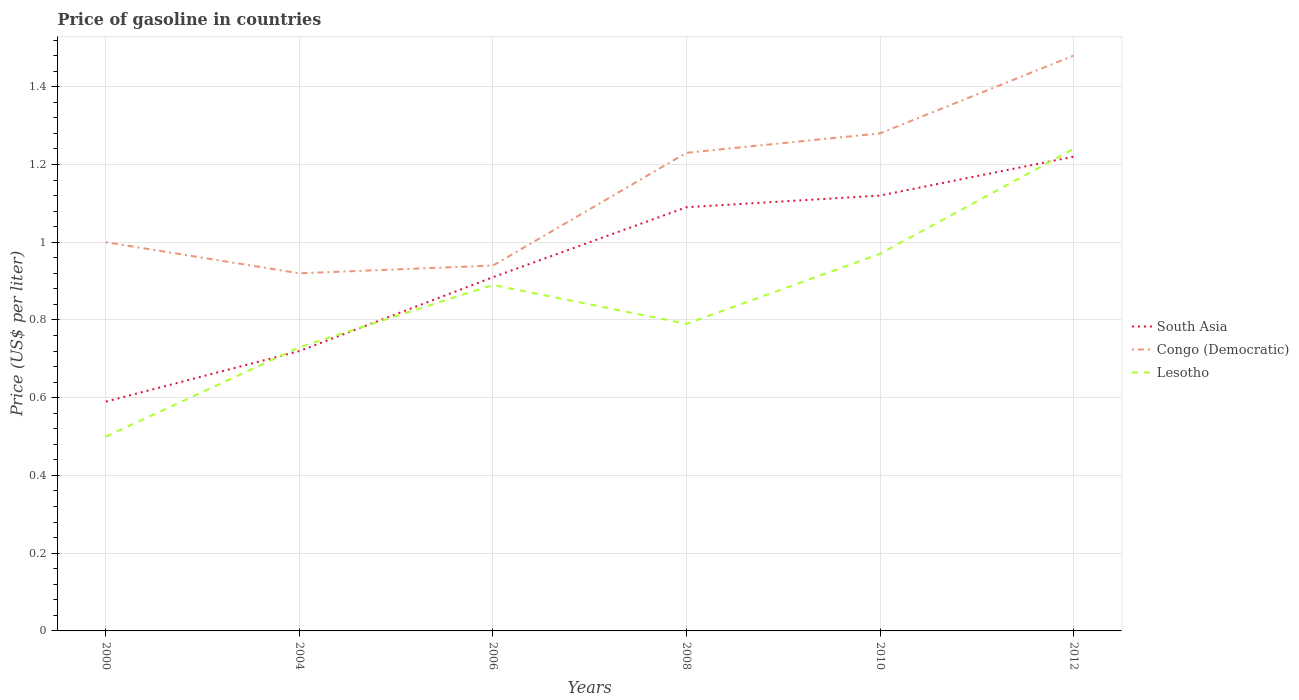Does the line corresponding to Lesotho intersect with the line corresponding to Congo (Democratic)?
Make the answer very short. No. Across all years, what is the maximum price of gasoline in Congo (Democratic)?
Your answer should be very brief. 0.92. What is the total price of gasoline in South Asia in the graph?
Keep it short and to the point. -0.1. What is the difference between the highest and the second highest price of gasoline in Congo (Democratic)?
Give a very brief answer. 0.56. What is the difference between the highest and the lowest price of gasoline in Congo (Democratic)?
Your answer should be very brief. 3. Are the values on the major ticks of Y-axis written in scientific E-notation?
Your answer should be compact. No. Where does the legend appear in the graph?
Offer a very short reply. Center right. How are the legend labels stacked?
Keep it short and to the point. Vertical. What is the title of the graph?
Provide a succinct answer. Price of gasoline in countries. Does "Libya" appear as one of the legend labels in the graph?
Offer a terse response. No. What is the label or title of the X-axis?
Provide a short and direct response. Years. What is the label or title of the Y-axis?
Your response must be concise. Price (US$ per liter). What is the Price (US$ per liter) in South Asia in 2000?
Keep it short and to the point. 0.59. What is the Price (US$ per liter) in Congo (Democratic) in 2000?
Give a very brief answer. 1. What is the Price (US$ per liter) of Lesotho in 2000?
Offer a terse response. 0.5. What is the Price (US$ per liter) in South Asia in 2004?
Ensure brevity in your answer.  0.72. What is the Price (US$ per liter) of Congo (Democratic) in 2004?
Provide a succinct answer. 0.92. What is the Price (US$ per liter) in Lesotho in 2004?
Offer a very short reply. 0.73. What is the Price (US$ per liter) of South Asia in 2006?
Your answer should be very brief. 0.91. What is the Price (US$ per liter) in Lesotho in 2006?
Offer a very short reply. 0.89. What is the Price (US$ per liter) in South Asia in 2008?
Offer a very short reply. 1.09. What is the Price (US$ per liter) of Congo (Democratic) in 2008?
Your response must be concise. 1.23. What is the Price (US$ per liter) of Lesotho in 2008?
Your answer should be very brief. 0.79. What is the Price (US$ per liter) in South Asia in 2010?
Keep it short and to the point. 1.12. What is the Price (US$ per liter) of Congo (Democratic) in 2010?
Provide a short and direct response. 1.28. What is the Price (US$ per liter) of South Asia in 2012?
Offer a very short reply. 1.22. What is the Price (US$ per liter) of Congo (Democratic) in 2012?
Ensure brevity in your answer.  1.48. What is the Price (US$ per liter) of Lesotho in 2012?
Offer a very short reply. 1.24. Across all years, what is the maximum Price (US$ per liter) of South Asia?
Offer a very short reply. 1.22. Across all years, what is the maximum Price (US$ per liter) of Congo (Democratic)?
Provide a succinct answer. 1.48. Across all years, what is the maximum Price (US$ per liter) in Lesotho?
Your response must be concise. 1.24. Across all years, what is the minimum Price (US$ per liter) in South Asia?
Your answer should be very brief. 0.59. Across all years, what is the minimum Price (US$ per liter) in Congo (Democratic)?
Offer a terse response. 0.92. What is the total Price (US$ per liter) of South Asia in the graph?
Give a very brief answer. 5.65. What is the total Price (US$ per liter) in Congo (Democratic) in the graph?
Make the answer very short. 6.85. What is the total Price (US$ per liter) in Lesotho in the graph?
Ensure brevity in your answer.  5.12. What is the difference between the Price (US$ per liter) of South Asia in 2000 and that in 2004?
Ensure brevity in your answer.  -0.13. What is the difference between the Price (US$ per liter) in Lesotho in 2000 and that in 2004?
Your answer should be very brief. -0.23. What is the difference between the Price (US$ per liter) in South Asia in 2000 and that in 2006?
Your answer should be compact. -0.32. What is the difference between the Price (US$ per liter) in Congo (Democratic) in 2000 and that in 2006?
Provide a succinct answer. 0.06. What is the difference between the Price (US$ per liter) in Lesotho in 2000 and that in 2006?
Ensure brevity in your answer.  -0.39. What is the difference between the Price (US$ per liter) in Congo (Democratic) in 2000 and that in 2008?
Ensure brevity in your answer.  -0.23. What is the difference between the Price (US$ per liter) in Lesotho in 2000 and that in 2008?
Keep it short and to the point. -0.29. What is the difference between the Price (US$ per liter) of South Asia in 2000 and that in 2010?
Give a very brief answer. -0.53. What is the difference between the Price (US$ per liter) of Congo (Democratic) in 2000 and that in 2010?
Your answer should be compact. -0.28. What is the difference between the Price (US$ per liter) of Lesotho in 2000 and that in 2010?
Keep it short and to the point. -0.47. What is the difference between the Price (US$ per liter) in South Asia in 2000 and that in 2012?
Provide a short and direct response. -0.63. What is the difference between the Price (US$ per liter) of Congo (Democratic) in 2000 and that in 2012?
Ensure brevity in your answer.  -0.48. What is the difference between the Price (US$ per liter) in Lesotho in 2000 and that in 2012?
Ensure brevity in your answer.  -0.74. What is the difference between the Price (US$ per liter) of South Asia in 2004 and that in 2006?
Offer a very short reply. -0.19. What is the difference between the Price (US$ per liter) in Congo (Democratic) in 2004 and that in 2006?
Your answer should be very brief. -0.02. What is the difference between the Price (US$ per liter) of Lesotho in 2004 and that in 2006?
Keep it short and to the point. -0.16. What is the difference between the Price (US$ per liter) in South Asia in 2004 and that in 2008?
Give a very brief answer. -0.37. What is the difference between the Price (US$ per liter) in Congo (Democratic) in 2004 and that in 2008?
Your answer should be very brief. -0.31. What is the difference between the Price (US$ per liter) in Lesotho in 2004 and that in 2008?
Your response must be concise. -0.06. What is the difference between the Price (US$ per liter) in South Asia in 2004 and that in 2010?
Your answer should be very brief. -0.4. What is the difference between the Price (US$ per liter) of Congo (Democratic) in 2004 and that in 2010?
Your response must be concise. -0.36. What is the difference between the Price (US$ per liter) in Lesotho in 2004 and that in 2010?
Your response must be concise. -0.24. What is the difference between the Price (US$ per liter) of Congo (Democratic) in 2004 and that in 2012?
Provide a short and direct response. -0.56. What is the difference between the Price (US$ per liter) in Lesotho in 2004 and that in 2012?
Offer a terse response. -0.51. What is the difference between the Price (US$ per liter) in South Asia in 2006 and that in 2008?
Make the answer very short. -0.18. What is the difference between the Price (US$ per liter) in Congo (Democratic) in 2006 and that in 2008?
Provide a short and direct response. -0.29. What is the difference between the Price (US$ per liter) in South Asia in 2006 and that in 2010?
Ensure brevity in your answer.  -0.21. What is the difference between the Price (US$ per liter) of Congo (Democratic) in 2006 and that in 2010?
Your response must be concise. -0.34. What is the difference between the Price (US$ per liter) of Lesotho in 2006 and that in 2010?
Offer a very short reply. -0.08. What is the difference between the Price (US$ per liter) in South Asia in 2006 and that in 2012?
Make the answer very short. -0.31. What is the difference between the Price (US$ per liter) in Congo (Democratic) in 2006 and that in 2012?
Provide a succinct answer. -0.54. What is the difference between the Price (US$ per liter) in Lesotho in 2006 and that in 2012?
Keep it short and to the point. -0.35. What is the difference between the Price (US$ per liter) of South Asia in 2008 and that in 2010?
Ensure brevity in your answer.  -0.03. What is the difference between the Price (US$ per liter) of Lesotho in 2008 and that in 2010?
Offer a very short reply. -0.18. What is the difference between the Price (US$ per liter) of South Asia in 2008 and that in 2012?
Your answer should be compact. -0.13. What is the difference between the Price (US$ per liter) of Lesotho in 2008 and that in 2012?
Provide a succinct answer. -0.45. What is the difference between the Price (US$ per liter) in Lesotho in 2010 and that in 2012?
Your answer should be compact. -0.27. What is the difference between the Price (US$ per liter) in South Asia in 2000 and the Price (US$ per liter) in Congo (Democratic) in 2004?
Your answer should be very brief. -0.33. What is the difference between the Price (US$ per liter) of South Asia in 2000 and the Price (US$ per liter) of Lesotho in 2004?
Ensure brevity in your answer.  -0.14. What is the difference between the Price (US$ per liter) of Congo (Democratic) in 2000 and the Price (US$ per liter) of Lesotho in 2004?
Your answer should be very brief. 0.27. What is the difference between the Price (US$ per liter) of South Asia in 2000 and the Price (US$ per liter) of Congo (Democratic) in 2006?
Offer a very short reply. -0.35. What is the difference between the Price (US$ per liter) in South Asia in 2000 and the Price (US$ per liter) in Lesotho in 2006?
Offer a terse response. -0.3. What is the difference between the Price (US$ per liter) in Congo (Democratic) in 2000 and the Price (US$ per liter) in Lesotho in 2006?
Provide a succinct answer. 0.11. What is the difference between the Price (US$ per liter) in South Asia in 2000 and the Price (US$ per liter) in Congo (Democratic) in 2008?
Keep it short and to the point. -0.64. What is the difference between the Price (US$ per liter) of Congo (Democratic) in 2000 and the Price (US$ per liter) of Lesotho in 2008?
Your answer should be very brief. 0.21. What is the difference between the Price (US$ per liter) in South Asia in 2000 and the Price (US$ per liter) in Congo (Democratic) in 2010?
Keep it short and to the point. -0.69. What is the difference between the Price (US$ per liter) of South Asia in 2000 and the Price (US$ per liter) of Lesotho in 2010?
Keep it short and to the point. -0.38. What is the difference between the Price (US$ per liter) in Congo (Democratic) in 2000 and the Price (US$ per liter) in Lesotho in 2010?
Make the answer very short. 0.03. What is the difference between the Price (US$ per liter) of South Asia in 2000 and the Price (US$ per liter) of Congo (Democratic) in 2012?
Keep it short and to the point. -0.89. What is the difference between the Price (US$ per liter) of South Asia in 2000 and the Price (US$ per liter) of Lesotho in 2012?
Provide a succinct answer. -0.65. What is the difference between the Price (US$ per liter) of Congo (Democratic) in 2000 and the Price (US$ per liter) of Lesotho in 2012?
Offer a terse response. -0.24. What is the difference between the Price (US$ per liter) of South Asia in 2004 and the Price (US$ per liter) of Congo (Democratic) in 2006?
Offer a terse response. -0.22. What is the difference between the Price (US$ per liter) in South Asia in 2004 and the Price (US$ per liter) in Lesotho in 2006?
Offer a terse response. -0.17. What is the difference between the Price (US$ per liter) of Congo (Democratic) in 2004 and the Price (US$ per liter) of Lesotho in 2006?
Your response must be concise. 0.03. What is the difference between the Price (US$ per liter) in South Asia in 2004 and the Price (US$ per liter) in Congo (Democratic) in 2008?
Provide a succinct answer. -0.51. What is the difference between the Price (US$ per liter) in South Asia in 2004 and the Price (US$ per liter) in Lesotho in 2008?
Provide a succinct answer. -0.07. What is the difference between the Price (US$ per liter) in Congo (Democratic) in 2004 and the Price (US$ per liter) in Lesotho in 2008?
Make the answer very short. 0.13. What is the difference between the Price (US$ per liter) of South Asia in 2004 and the Price (US$ per liter) of Congo (Democratic) in 2010?
Ensure brevity in your answer.  -0.56. What is the difference between the Price (US$ per liter) in Congo (Democratic) in 2004 and the Price (US$ per liter) in Lesotho in 2010?
Your answer should be compact. -0.05. What is the difference between the Price (US$ per liter) of South Asia in 2004 and the Price (US$ per liter) of Congo (Democratic) in 2012?
Your answer should be very brief. -0.76. What is the difference between the Price (US$ per liter) in South Asia in 2004 and the Price (US$ per liter) in Lesotho in 2012?
Make the answer very short. -0.52. What is the difference between the Price (US$ per liter) in Congo (Democratic) in 2004 and the Price (US$ per liter) in Lesotho in 2012?
Make the answer very short. -0.32. What is the difference between the Price (US$ per liter) of South Asia in 2006 and the Price (US$ per liter) of Congo (Democratic) in 2008?
Your answer should be very brief. -0.32. What is the difference between the Price (US$ per liter) of South Asia in 2006 and the Price (US$ per liter) of Lesotho in 2008?
Keep it short and to the point. 0.12. What is the difference between the Price (US$ per liter) in Congo (Democratic) in 2006 and the Price (US$ per liter) in Lesotho in 2008?
Make the answer very short. 0.15. What is the difference between the Price (US$ per liter) of South Asia in 2006 and the Price (US$ per liter) of Congo (Democratic) in 2010?
Give a very brief answer. -0.37. What is the difference between the Price (US$ per liter) of South Asia in 2006 and the Price (US$ per liter) of Lesotho in 2010?
Make the answer very short. -0.06. What is the difference between the Price (US$ per liter) of Congo (Democratic) in 2006 and the Price (US$ per liter) of Lesotho in 2010?
Provide a succinct answer. -0.03. What is the difference between the Price (US$ per liter) of South Asia in 2006 and the Price (US$ per liter) of Congo (Democratic) in 2012?
Ensure brevity in your answer.  -0.57. What is the difference between the Price (US$ per liter) of South Asia in 2006 and the Price (US$ per liter) of Lesotho in 2012?
Provide a short and direct response. -0.33. What is the difference between the Price (US$ per liter) of Congo (Democratic) in 2006 and the Price (US$ per liter) of Lesotho in 2012?
Offer a terse response. -0.3. What is the difference between the Price (US$ per liter) in South Asia in 2008 and the Price (US$ per liter) in Congo (Democratic) in 2010?
Keep it short and to the point. -0.19. What is the difference between the Price (US$ per liter) of South Asia in 2008 and the Price (US$ per liter) of Lesotho in 2010?
Provide a short and direct response. 0.12. What is the difference between the Price (US$ per liter) of Congo (Democratic) in 2008 and the Price (US$ per liter) of Lesotho in 2010?
Keep it short and to the point. 0.26. What is the difference between the Price (US$ per liter) in South Asia in 2008 and the Price (US$ per liter) in Congo (Democratic) in 2012?
Your answer should be very brief. -0.39. What is the difference between the Price (US$ per liter) of South Asia in 2008 and the Price (US$ per liter) of Lesotho in 2012?
Offer a very short reply. -0.15. What is the difference between the Price (US$ per liter) of Congo (Democratic) in 2008 and the Price (US$ per liter) of Lesotho in 2012?
Give a very brief answer. -0.01. What is the difference between the Price (US$ per liter) in South Asia in 2010 and the Price (US$ per liter) in Congo (Democratic) in 2012?
Your response must be concise. -0.36. What is the difference between the Price (US$ per liter) of South Asia in 2010 and the Price (US$ per liter) of Lesotho in 2012?
Your response must be concise. -0.12. What is the average Price (US$ per liter) of South Asia per year?
Your response must be concise. 0.94. What is the average Price (US$ per liter) of Congo (Democratic) per year?
Provide a succinct answer. 1.14. What is the average Price (US$ per liter) in Lesotho per year?
Keep it short and to the point. 0.85. In the year 2000, what is the difference between the Price (US$ per liter) of South Asia and Price (US$ per liter) of Congo (Democratic)?
Your response must be concise. -0.41. In the year 2000, what is the difference between the Price (US$ per liter) in South Asia and Price (US$ per liter) in Lesotho?
Make the answer very short. 0.09. In the year 2000, what is the difference between the Price (US$ per liter) of Congo (Democratic) and Price (US$ per liter) of Lesotho?
Your response must be concise. 0.5. In the year 2004, what is the difference between the Price (US$ per liter) of South Asia and Price (US$ per liter) of Lesotho?
Your response must be concise. -0.01. In the year 2004, what is the difference between the Price (US$ per liter) of Congo (Democratic) and Price (US$ per liter) of Lesotho?
Offer a terse response. 0.19. In the year 2006, what is the difference between the Price (US$ per liter) of South Asia and Price (US$ per liter) of Congo (Democratic)?
Your answer should be compact. -0.03. In the year 2006, what is the difference between the Price (US$ per liter) in South Asia and Price (US$ per liter) in Lesotho?
Your answer should be very brief. 0.02. In the year 2006, what is the difference between the Price (US$ per liter) in Congo (Democratic) and Price (US$ per liter) in Lesotho?
Your answer should be very brief. 0.05. In the year 2008, what is the difference between the Price (US$ per liter) in South Asia and Price (US$ per liter) in Congo (Democratic)?
Keep it short and to the point. -0.14. In the year 2008, what is the difference between the Price (US$ per liter) of Congo (Democratic) and Price (US$ per liter) of Lesotho?
Provide a succinct answer. 0.44. In the year 2010, what is the difference between the Price (US$ per liter) in South Asia and Price (US$ per liter) in Congo (Democratic)?
Offer a terse response. -0.16. In the year 2010, what is the difference between the Price (US$ per liter) of South Asia and Price (US$ per liter) of Lesotho?
Your answer should be compact. 0.15. In the year 2010, what is the difference between the Price (US$ per liter) of Congo (Democratic) and Price (US$ per liter) of Lesotho?
Offer a terse response. 0.31. In the year 2012, what is the difference between the Price (US$ per liter) in South Asia and Price (US$ per liter) in Congo (Democratic)?
Provide a succinct answer. -0.26. In the year 2012, what is the difference between the Price (US$ per liter) of South Asia and Price (US$ per liter) of Lesotho?
Your response must be concise. -0.02. In the year 2012, what is the difference between the Price (US$ per liter) in Congo (Democratic) and Price (US$ per liter) in Lesotho?
Keep it short and to the point. 0.24. What is the ratio of the Price (US$ per liter) of South Asia in 2000 to that in 2004?
Your response must be concise. 0.82. What is the ratio of the Price (US$ per liter) of Congo (Democratic) in 2000 to that in 2004?
Your answer should be compact. 1.09. What is the ratio of the Price (US$ per liter) in Lesotho in 2000 to that in 2004?
Give a very brief answer. 0.68. What is the ratio of the Price (US$ per liter) of South Asia in 2000 to that in 2006?
Keep it short and to the point. 0.65. What is the ratio of the Price (US$ per liter) in Congo (Democratic) in 2000 to that in 2006?
Provide a succinct answer. 1.06. What is the ratio of the Price (US$ per liter) of Lesotho in 2000 to that in 2006?
Provide a succinct answer. 0.56. What is the ratio of the Price (US$ per liter) in South Asia in 2000 to that in 2008?
Provide a succinct answer. 0.54. What is the ratio of the Price (US$ per liter) of Congo (Democratic) in 2000 to that in 2008?
Your answer should be very brief. 0.81. What is the ratio of the Price (US$ per liter) of Lesotho in 2000 to that in 2008?
Keep it short and to the point. 0.63. What is the ratio of the Price (US$ per liter) in South Asia in 2000 to that in 2010?
Offer a very short reply. 0.53. What is the ratio of the Price (US$ per liter) of Congo (Democratic) in 2000 to that in 2010?
Keep it short and to the point. 0.78. What is the ratio of the Price (US$ per liter) of Lesotho in 2000 to that in 2010?
Your response must be concise. 0.52. What is the ratio of the Price (US$ per liter) in South Asia in 2000 to that in 2012?
Offer a terse response. 0.48. What is the ratio of the Price (US$ per liter) of Congo (Democratic) in 2000 to that in 2012?
Give a very brief answer. 0.68. What is the ratio of the Price (US$ per liter) of Lesotho in 2000 to that in 2012?
Give a very brief answer. 0.4. What is the ratio of the Price (US$ per liter) of South Asia in 2004 to that in 2006?
Offer a terse response. 0.79. What is the ratio of the Price (US$ per liter) in Congo (Democratic) in 2004 to that in 2006?
Keep it short and to the point. 0.98. What is the ratio of the Price (US$ per liter) in Lesotho in 2004 to that in 2006?
Ensure brevity in your answer.  0.82. What is the ratio of the Price (US$ per liter) of South Asia in 2004 to that in 2008?
Provide a short and direct response. 0.66. What is the ratio of the Price (US$ per liter) of Congo (Democratic) in 2004 to that in 2008?
Ensure brevity in your answer.  0.75. What is the ratio of the Price (US$ per liter) in Lesotho in 2004 to that in 2008?
Keep it short and to the point. 0.92. What is the ratio of the Price (US$ per liter) in South Asia in 2004 to that in 2010?
Provide a short and direct response. 0.64. What is the ratio of the Price (US$ per liter) in Congo (Democratic) in 2004 to that in 2010?
Offer a terse response. 0.72. What is the ratio of the Price (US$ per liter) in Lesotho in 2004 to that in 2010?
Make the answer very short. 0.75. What is the ratio of the Price (US$ per liter) of South Asia in 2004 to that in 2012?
Ensure brevity in your answer.  0.59. What is the ratio of the Price (US$ per liter) of Congo (Democratic) in 2004 to that in 2012?
Provide a succinct answer. 0.62. What is the ratio of the Price (US$ per liter) of Lesotho in 2004 to that in 2012?
Offer a terse response. 0.59. What is the ratio of the Price (US$ per liter) of South Asia in 2006 to that in 2008?
Ensure brevity in your answer.  0.83. What is the ratio of the Price (US$ per liter) in Congo (Democratic) in 2006 to that in 2008?
Offer a very short reply. 0.76. What is the ratio of the Price (US$ per liter) in Lesotho in 2006 to that in 2008?
Give a very brief answer. 1.13. What is the ratio of the Price (US$ per liter) in South Asia in 2006 to that in 2010?
Keep it short and to the point. 0.81. What is the ratio of the Price (US$ per liter) of Congo (Democratic) in 2006 to that in 2010?
Give a very brief answer. 0.73. What is the ratio of the Price (US$ per liter) in Lesotho in 2006 to that in 2010?
Your response must be concise. 0.92. What is the ratio of the Price (US$ per liter) of South Asia in 2006 to that in 2012?
Provide a short and direct response. 0.75. What is the ratio of the Price (US$ per liter) of Congo (Democratic) in 2006 to that in 2012?
Make the answer very short. 0.64. What is the ratio of the Price (US$ per liter) of Lesotho in 2006 to that in 2012?
Your response must be concise. 0.72. What is the ratio of the Price (US$ per liter) in South Asia in 2008 to that in 2010?
Offer a terse response. 0.97. What is the ratio of the Price (US$ per liter) of Congo (Democratic) in 2008 to that in 2010?
Offer a very short reply. 0.96. What is the ratio of the Price (US$ per liter) of Lesotho in 2008 to that in 2010?
Your response must be concise. 0.81. What is the ratio of the Price (US$ per liter) in South Asia in 2008 to that in 2012?
Your answer should be very brief. 0.89. What is the ratio of the Price (US$ per liter) in Congo (Democratic) in 2008 to that in 2012?
Keep it short and to the point. 0.83. What is the ratio of the Price (US$ per liter) of Lesotho in 2008 to that in 2012?
Ensure brevity in your answer.  0.64. What is the ratio of the Price (US$ per liter) of South Asia in 2010 to that in 2012?
Give a very brief answer. 0.92. What is the ratio of the Price (US$ per liter) of Congo (Democratic) in 2010 to that in 2012?
Provide a succinct answer. 0.86. What is the ratio of the Price (US$ per liter) of Lesotho in 2010 to that in 2012?
Your answer should be very brief. 0.78. What is the difference between the highest and the second highest Price (US$ per liter) in South Asia?
Offer a very short reply. 0.1. What is the difference between the highest and the second highest Price (US$ per liter) of Lesotho?
Provide a succinct answer. 0.27. What is the difference between the highest and the lowest Price (US$ per liter) of South Asia?
Offer a very short reply. 0.63. What is the difference between the highest and the lowest Price (US$ per liter) in Congo (Democratic)?
Your answer should be very brief. 0.56. What is the difference between the highest and the lowest Price (US$ per liter) in Lesotho?
Provide a short and direct response. 0.74. 